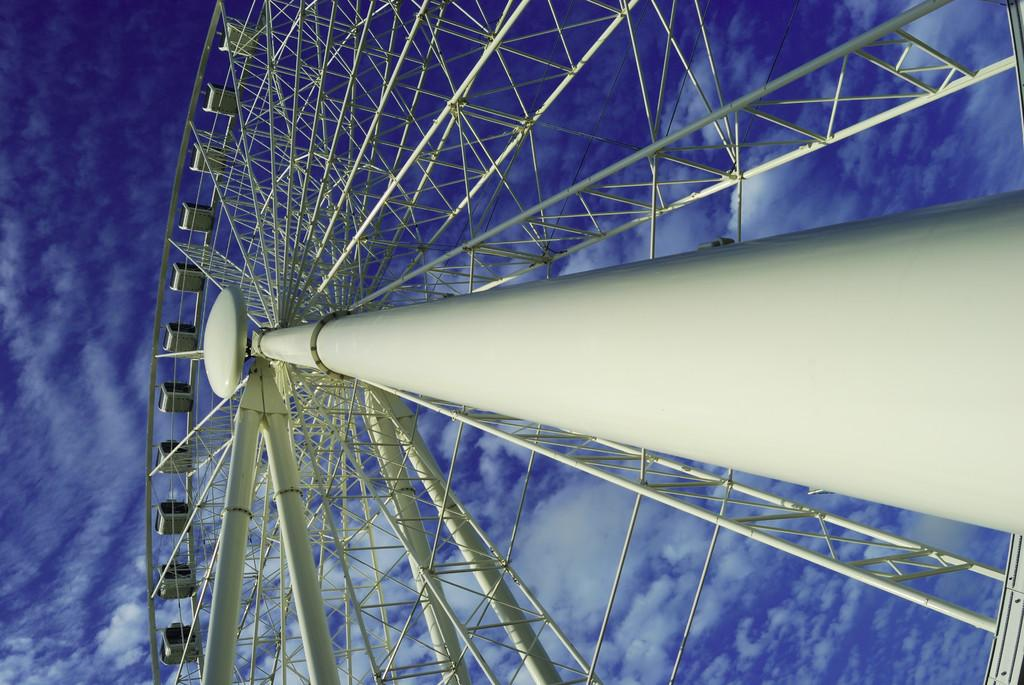What is the main subject of the image? There is a Ferris wheel in the image. What can be seen in the background of the image? The sky is visible in the background of the image. What is the aftermath of the accident at the attraction in the image? There is no mention of an accident or attraction in the image; it only features a Ferris wheel and the sky. 